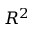Convert formula to latex. <formula><loc_0><loc_0><loc_500><loc_500>R ^ { 2 }</formula> 